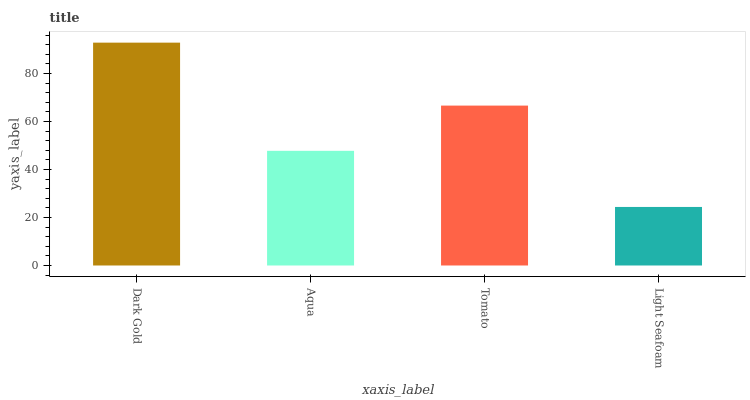Is Light Seafoam the minimum?
Answer yes or no. Yes. Is Dark Gold the maximum?
Answer yes or no. Yes. Is Aqua the minimum?
Answer yes or no. No. Is Aqua the maximum?
Answer yes or no. No. Is Dark Gold greater than Aqua?
Answer yes or no. Yes. Is Aqua less than Dark Gold?
Answer yes or no. Yes. Is Aqua greater than Dark Gold?
Answer yes or no. No. Is Dark Gold less than Aqua?
Answer yes or no. No. Is Tomato the high median?
Answer yes or no. Yes. Is Aqua the low median?
Answer yes or no. Yes. Is Aqua the high median?
Answer yes or no. No. Is Tomato the low median?
Answer yes or no. No. 